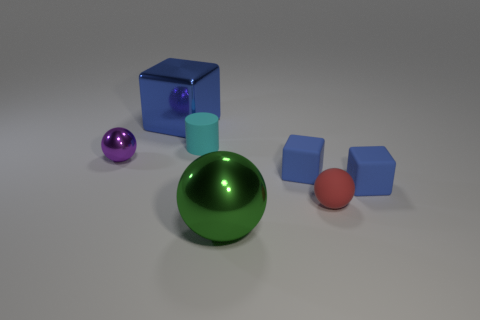Are there the same number of green objects that are behind the large ball and cylinders in front of the tiny cyan cylinder?
Provide a short and direct response. Yes. There is a cylinder that is the same material as the tiny red object; what is its size?
Keep it short and to the point. Small. What is the color of the large cube?
Provide a succinct answer. Blue. How many blocks have the same color as the small metal sphere?
Give a very brief answer. 0. What is the material of the cyan object that is the same size as the matte ball?
Ensure brevity in your answer.  Rubber. Are there any blue shiny cubes in front of the small sphere to the right of the big blue metal block?
Offer a very short reply. No. How many other things are the same color as the large shiny block?
Your answer should be very brief. 2. The purple shiny thing is what size?
Provide a short and direct response. Small. Are there any large gray metallic cubes?
Provide a succinct answer. No. Is the number of objects that are in front of the large cube greater than the number of large blue things in front of the large sphere?
Your answer should be compact. Yes. 